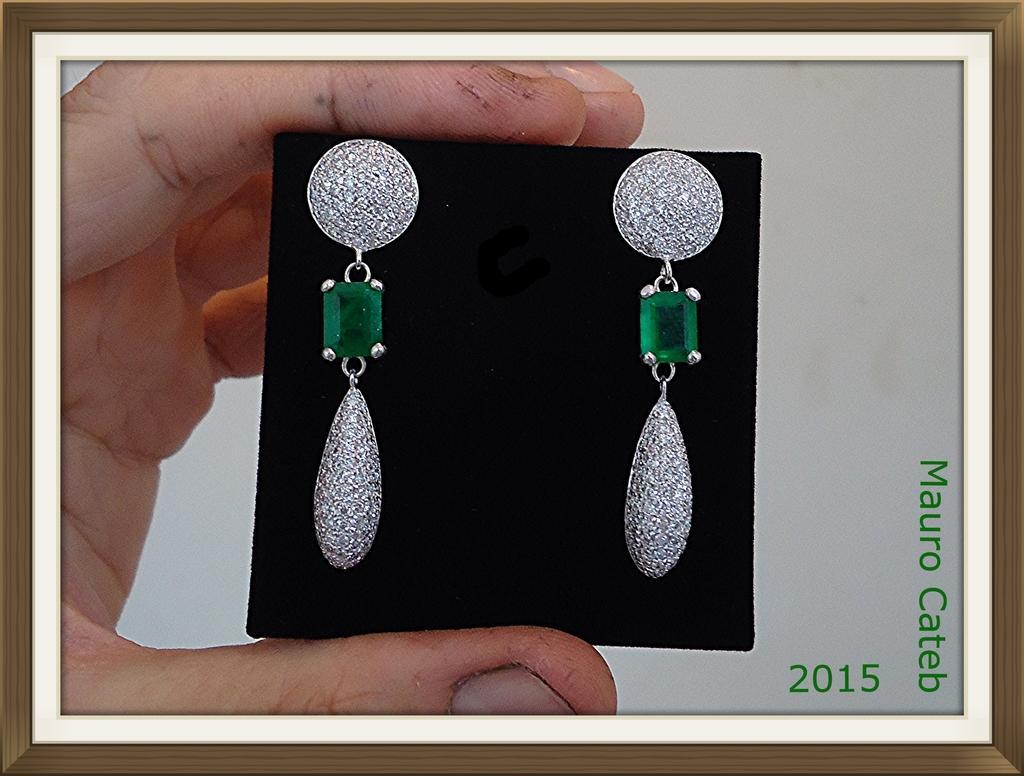Describe this image in one or two sentences. In this picture we can see hand of a person holding earrings. 